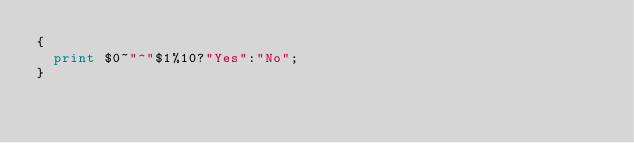Convert code to text. <code><loc_0><loc_0><loc_500><loc_500><_Awk_>{
  print $0~"^"$1%10?"Yes":"No";
}</code> 